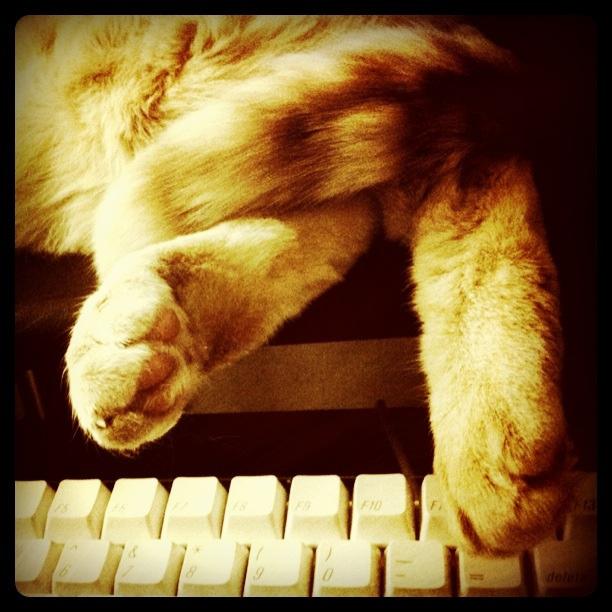What kind of animal do you think this is?
Answer briefly. Cat. Will the animal step on the keys?
Give a very brief answer. Yes. Why do some of the keys appear blank?
Concise answer only. Lighting. 